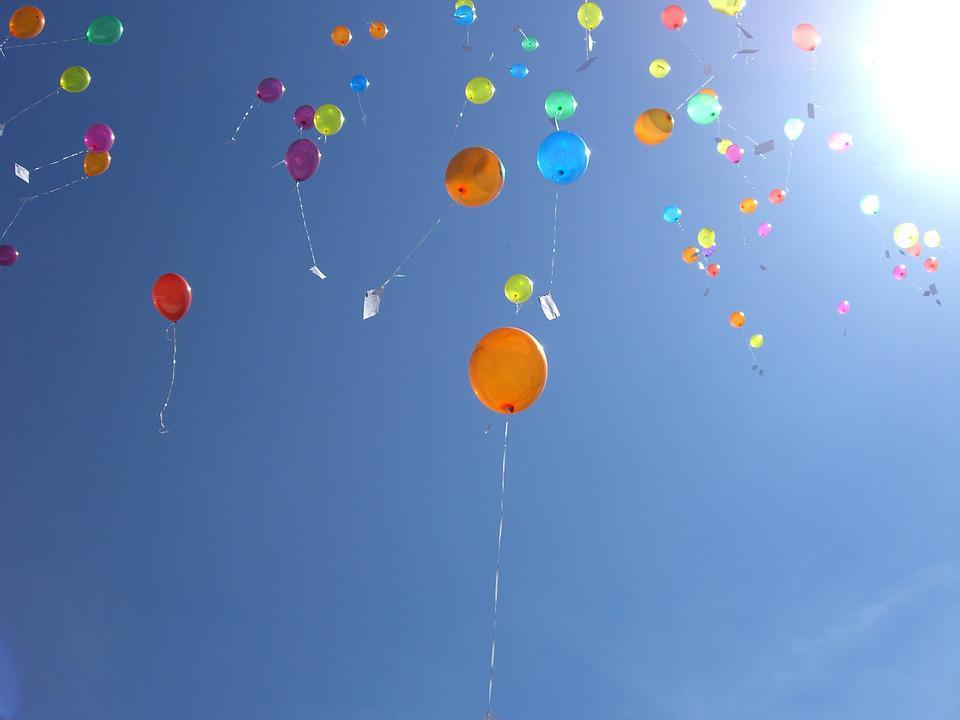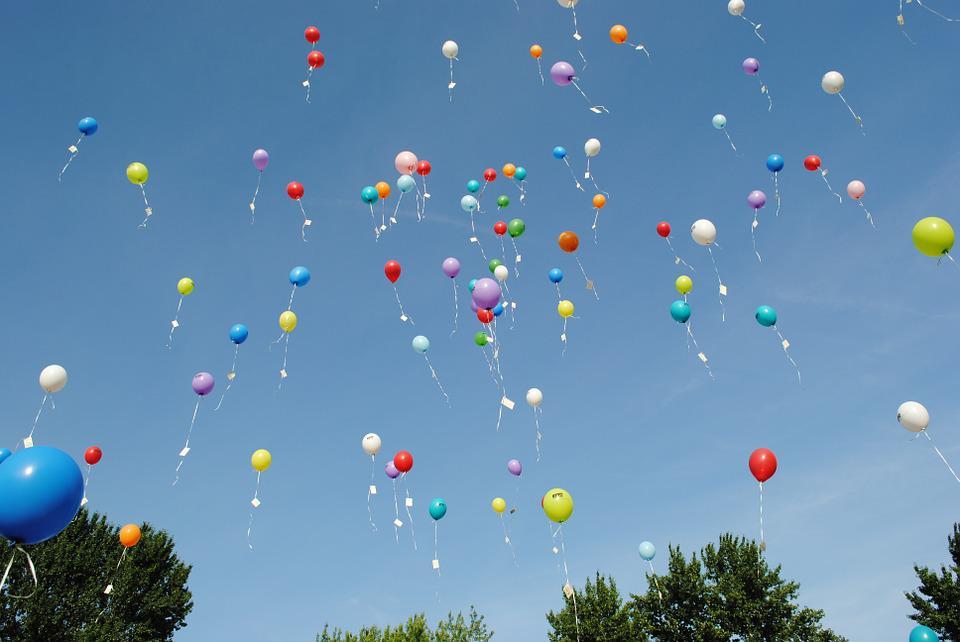The first image is the image on the left, the second image is the image on the right. Examine the images to the left and right. Is the description "Both images show many different colored balloons against the blue sky." accurate? Answer yes or no. Yes. The first image is the image on the left, the second image is the image on the right. Analyze the images presented: Is the assertion "All images show more than six balloons in the air." valid? Answer yes or no. Yes. 